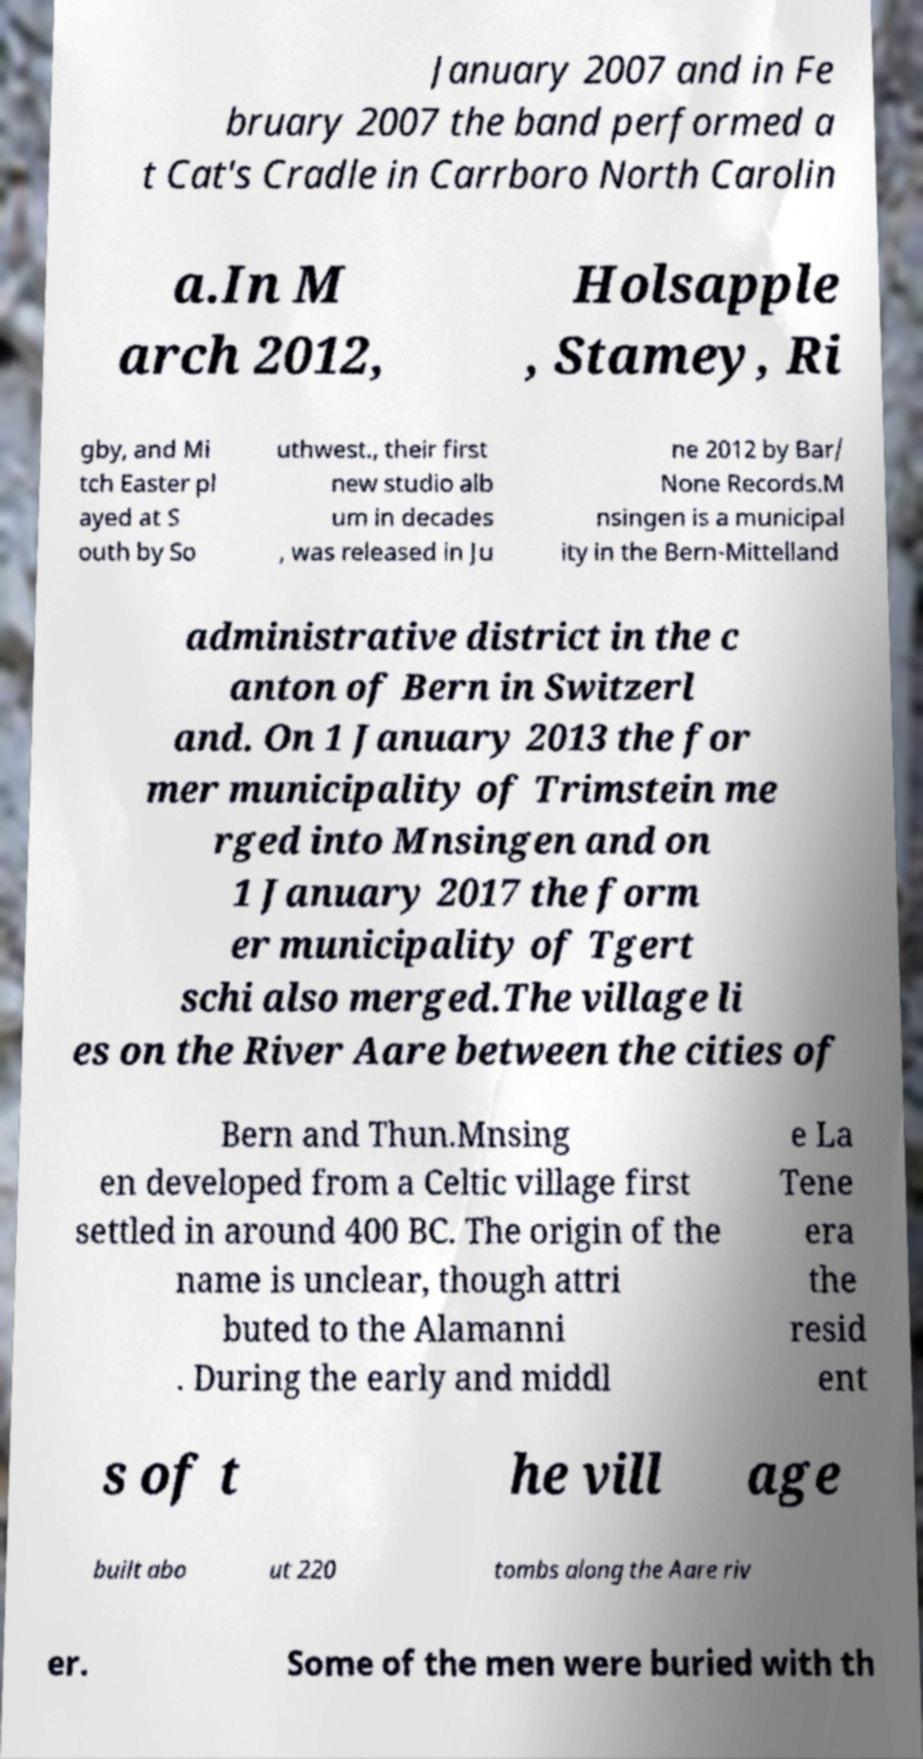I need the written content from this picture converted into text. Can you do that? January 2007 and in Fe bruary 2007 the band performed a t Cat's Cradle in Carrboro North Carolin a.In M arch 2012, Holsapple , Stamey, Ri gby, and Mi tch Easter pl ayed at S outh by So uthwest., their first new studio alb um in decades , was released in Ju ne 2012 by Bar/ None Records.M nsingen is a municipal ity in the Bern-Mittelland administrative district in the c anton of Bern in Switzerl and. On 1 January 2013 the for mer municipality of Trimstein me rged into Mnsingen and on 1 January 2017 the form er municipality of Tgert schi also merged.The village li es on the River Aare between the cities of Bern and Thun.Mnsing en developed from a Celtic village first settled in around 400 BC. The origin of the name is unclear, though attri buted to the Alamanni . During the early and middl e La Tene era the resid ent s of t he vill age built abo ut 220 tombs along the Aare riv er. Some of the men were buried with th 